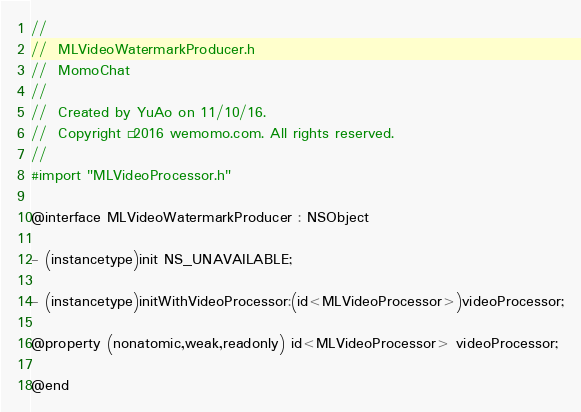Convert code to text. <code><loc_0><loc_0><loc_500><loc_500><_C_>//
//  MLVideoWatermarkProducer.h
//  MomoChat
//
//  Created by YuAo on 11/10/16.
//  Copyright © 2016 wemomo.com. All rights reserved.
//
#import "MLVideoProcessor.h"

@interface MLVideoWatermarkProducer : NSObject

- (instancetype)init NS_UNAVAILABLE;

- (instancetype)initWithVideoProcessor:(id<MLVideoProcessor>)videoProcessor;

@property (nonatomic,weak,readonly) id<MLVideoProcessor> videoProcessor;

@end
</code> 